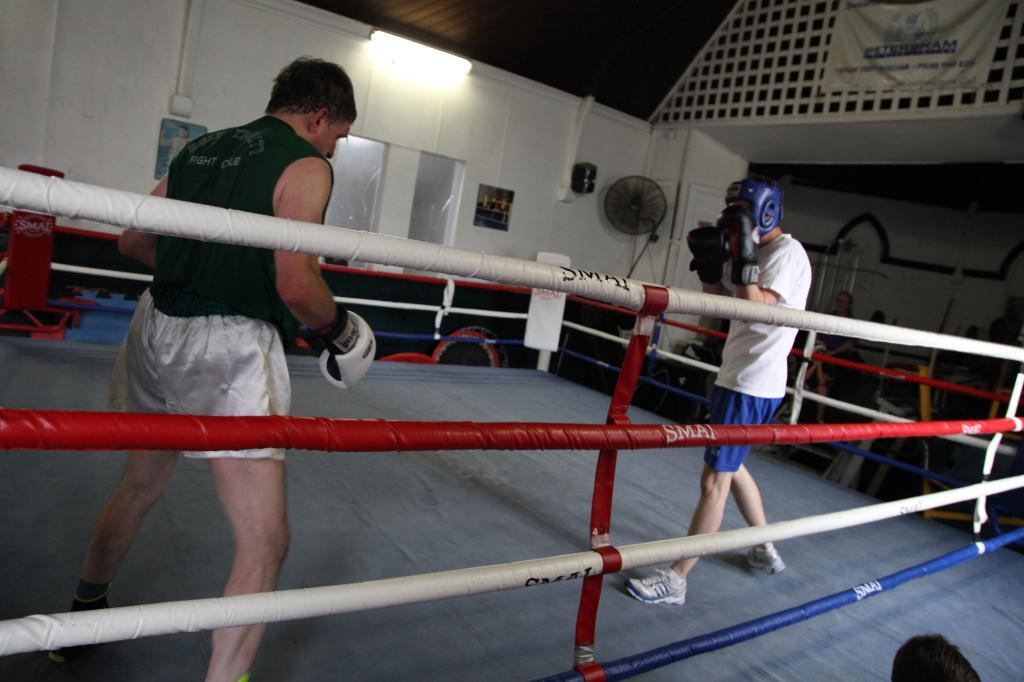How many people are in the image? There is a group of people in the image. Can you describe the attire of some of the people? Two people are wearing gloves. What objects are near the group of people? There are ropes beside the group of people. What can be seen in the background of the image? There is a fan, a light, and a flex in the background of the image. What type of fruit is being listed by the people in the image? There is no fruit or list present in the image. What type of education is being discussed by the people in the image? There is no discussion about education in the image. 